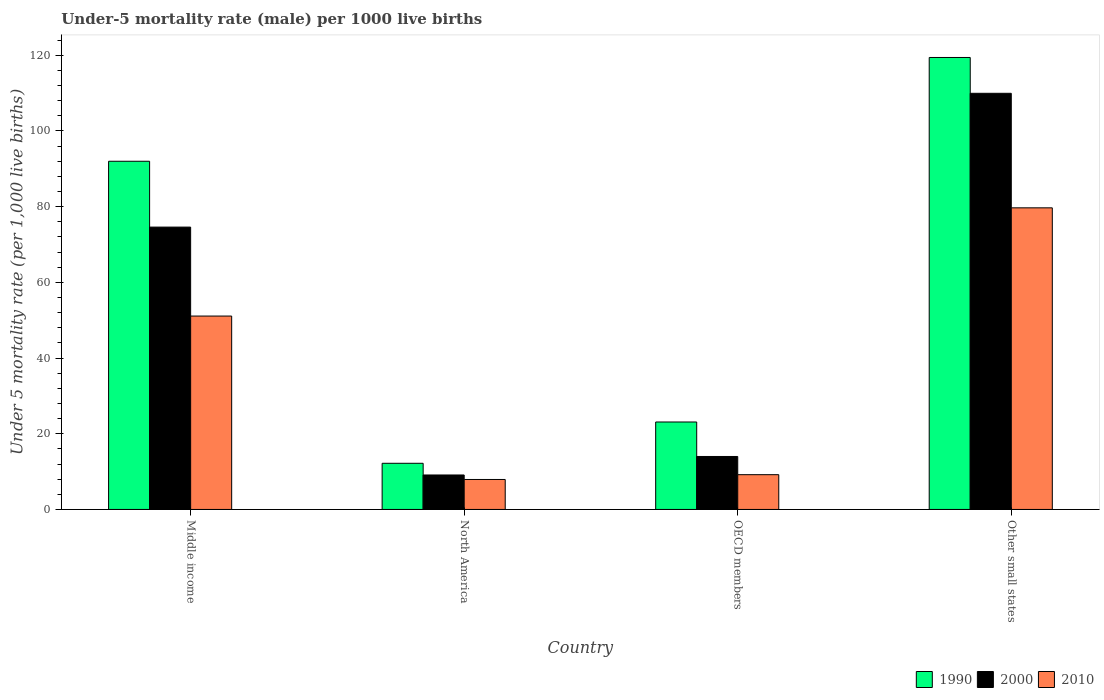How many groups of bars are there?
Your answer should be very brief. 4. Are the number of bars per tick equal to the number of legend labels?
Provide a succinct answer. Yes. Are the number of bars on each tick of the X-axis equal?
Provide a succinct answer. Yes. What is the under-five mortality rate in 2000 in Other small states?
Provide a succinct answer. 109.95. Across all countries, what is the maximum under-five mortality rate in 1990?
Provide a short and direct response. 119.42. Across all countries, what is the minimum under-five mortality rate in 1990?
Provide a succinct answer. 12.2. In which country was the under-five mortality rate in 2010 maximum?
Give a very brief answer. Other small states. In which country was the under-five mortality rate in 2000 minimum?
Your answer should be compact. North America. What is the total under-five mortality rate in 1990 in the graph?
Make the answer very short. 246.73. What is the difference between the under-five mortality rate in 2010 in North America and that in OECD members?
Offer a very short reply. -1.26. What is the difference between the under-five mortality rate in 1990 in OECD members and the under-five mortality rate in 2010 in Other small states?
Provide a succinct answer. -56.58. What is the average under-five mortality rate in 1990 per country?
Make the answer very short. 61.68. What is the difference between the under-five mortality rate of/in 2000 and under-five mortality rate of/in 2010 in OECD members?
Ensure brevity in your answer.  4.81. In how many countries, is the under-five mortality rate in 2000 greater than 68?
Your answer should be very brief. 2. What is the ratio of the under-five mortality rate in 2010 in Middle income to that in North America?
Make the answer very short. 6.45. Is the under-five mortality rate in 1990 in Middle income less than that in North America?
Ensure brevity in your answer.  No. What is the difference between the highest and the second highest under-five mortality rate in 1990?
Ensure brevity in your answer.  68.89. What is the difference between the highest and the lowest under-five mortality rate in 2000?
Give a very brief answer. 100.84. In how many countries, is the under-five mortality rate in 2010 greater than the average under-five mortality rate in 2010 taken over all countries?
Make the answer very short. 2. What does the 3rd bar from the left in Middle income represents?
Your response must be concise. 2010. Is it the case that in every country, the sum of the under-five mortality rate in 1990 and under-five mortality rate in 2010 is greater than the under-five mortality rate in 2000?
Keep it short and to the point. Yes. Are all the bars in the graph horizontal?
Your answer should be very brief. No. What is the difference between two consecutive major ticks on the Y-axis?
Make the answer very short. 20. Are the values on the major ticks of Y-axis written in scientific E-notation?
Provide a short and direct response. No. Does the graph contain any zero values?
Give a very brief answer. No. How many legend labels are there?
Give a very brief answer. 3. How are the legend labels stacked?
Your response must be concise. Horizontal. What is the title of the graph?
Offer a terse response. Under-5 mortality rate (male) per 1000 live births. What is the label or title of the Y-axis?
Ensure brevity in your answer.  Under 5 mortality rate (per 1,0 live births). What is the Under 5 mortality rate (per 1,000 live births) of 1990 in Middle income?
Your response must be concise. 92. What is the Under 5 mortality rate (per 1,000 live births) of 2000 in Middle income?
Give a very brief answer. 74.6. What is the Under 5 mortality rate (per 1,000 live births) of 2010 in Middle income?
Keep it short and to the point. 51.1. What is the Under 5 mortality rate (per 1,000 live births) of 1990 in North America?
Your response must be concise. 12.2. What is the Under 5 mortality rate (per 1,000 live births) in 2000 in North America?
Offer a terse response. 9.11. What is the Under 5 mortality rate (per 1,000 live births) in 2010 in North America?
Keep it short and to the point. 7.92. What is the Under 5 mortality rate (per 1,000 live births) of 1990 in OECD members?
Make the answer very short. 23.11. What is the Under 5 mortality rate (per 1,000 live births) in 2000 in OECD members?
Your response must be concise. 14. What is the Under 5 mortality rate (per 1,000 live births) of 2010 in OECD members?
Give a very brief answer. 9.19. What is the Under 5 mortality rate (per 1,000 live births) of 1990 in Other small states?
Offer a very short reply. 119.42. What is the Under 5 mortality rate (per 1,000 live births) in 2000 in Other small states?
Your response must be concise. 109.95. What is the Under 5 mortality rate (per 1,000 live births) of 2010 in Other small states?
Make the answer very short. 79.69. Across all countries, what is the maximum Under 5 mortality rate (per 1,000 live births) in 1990?
Provide a short and direct response. 119.42. Across all countries, what is the maximum Under 5 mortality rate (per 1,000 live births) in 2000?
Keep it short and to the point. 109.95. Across all countries, what is the maximum Under 5 mortality rate (per 1,000 live births) in 2010?
Your answer should be compact. 79.69. Across all countries, what is the minimum Under 5 mortality rate (per 1,000 live births) in 1990?
Make the answer very short. 12.2. Across all countries, what is the minimum Under 5 mortality rate (per 1,000 live births) in 2000?
Offer a very short reply. 9.11. Across all countries, what is the minimum Under 5 mortality rate (per 1,000 live births) in 2010?
Give a very brief answer. 7.92. What is the total Under 5 mortality rate (per 1,000 live births) in 1990 in the graph?
Make the answer very short. 246.73. What is the total Under 5 mortality rate (per 1,000 live births) of 2000 in the graph?
Provide a short and direct response. 207.66. What is the total Under 5 mortality rate (per 1,000 live births) of 2010 in the graph?
Give a very brief answer. 147.9. What is the difference between the Under 5 mortality rate (per 1,000 live births) of 1990 in Middle income and that in North America?
Your answer should be very brief. 79.8. What is the difference between the Under 5 mortality rate (per 1,000 live births) in 2000 in Middle income and that in North America?
Your answer should be compact. 65.49. What is the difference between the Under 5 mortality rate (per 1,000 live births) in 2010 in Middle income and that in North America?
Make the answer very short. 43.18. What is the difference between the Under 5 mortality rate (per 1,000 live births) of 1990 in Middle income and that in OECD members?
Your answer should be compact. 68.89. What is the difference between the Under 5 mortality rate (per 1,000 live births) in 2000 in Middle income and that in OECD members?
Ensure brevity in your answer.  60.6. What is the difference between the Under 5 mortality rate (per 1,000 live births) of 2010 in Middle income and that in OECD members?
Your answer should be compact. 41.91. What is the difference between the Under 5 mortality rate (per 1,000 live births) of 1990 in Middle income and that in Other small states?
Offer a terse response. -27.42. What is the difference between the Under 5 mortality rate (per 1,000 live births) of 2000 in Middle income and that in Other small states?
Give a very brief answer. -35.35. What is the difference between the Under 5 mortality rate (per 1,000 live births) of 2010 in Middle income and that in Other small states?
Your response must be concise. -28.59. What is the difference between the Under 5 mortality rate (per 1,000 live births) of 1990 in North America and that in OECD members?
Provide a short and direct response. -10.91. What is the difference between the Under 5 mortality rate (per 1,000 live births) of 2000 in North America and that in OECD members?
Provide a short and direct response. -4.89. What is the difference between the Under 5 mortality rate (per 1,000 live births) of 2010 in North America and that in OECD members?
Offer a very short reply. -1.26. What is the difference between the Under 5 mortality rate (per 1,000 live births) of 1990 in North America and that in Other small states?
Your response must be concise. -107.22. What is the difference between the Under 5 mortality rate (per 1,000 live births) in 2000 in North America and that in Other small states?
Keep it short and to the point. -100.84. What is the difference between the Under 5 mortality rate (per 1,000 live births) of 2010 in North America and that in Other small states?
Your response must be concise. -71.77. What is the difference between the Under 5 mortality rate (per 1,000 live births) of 1990 in OECD members and that in Other small states?
Keep it short and to the point. -96.31. What is the difference between the Under 5 mortality rate (per 1,000 live births) in 2000 in OECD members and that in Other small states?
Provide a succinct answer. -95.95. What is the difference between the Under 5 mortality rate (per 1,000 live births) in 2010 in OECD members and that in Other small states?
Offer a terse response. -70.51. What is the difference between the Under 5 mortality rate (per 1,000 live births) in 1990 in Middle income and the Under 5 mortality rate (per 1,000 live births) in 2000 in North America?
Give a very brief answer. 82.89. What is the difference between the Under 5 mortality rate (per 1,000 live births) in 1990 in Middle income and the Under 5 mortality rate (per 1,000 live births) in 2010 in North America?
Provide a succinct answer. 84.08. What is the difference between the Under 5 mortality rate (per 1,000 live births) in 2000 in Middle income and the Under 5 mortality rate (per 1,000 live births) in 2010 in North America?
Ensure brevity in your answer.  66.68. What is the difference between the Under 5 mortality rate (per 1,000 live births) in 1990 in Middle income and the Under 5 mortality rate (per 1,000 live births) in 2000 in OECD members?
Make the answer very short. 78. What is the difference between the Under 5 mortality rate (per 1,000 live births) in 1990 in Middle income and the Under 5 mortality rate (per 1,000 live births) in 2010 in OECD members?
Keep it short and to the point. 82.81. What is the difference between the Under 5 mortality rate (per 1,000 live births) in 2000 in Middle income and the Under 5 mortality rate (per 1,000 live births) in 2010 in OECD members?
Your response must be concise. 65.41. What is the difference between the Under 5 mortality rate (per 1,000 live births) of 1990 in Middle income and the Under 5 mortality rate (per 1,000 live births) of 2000 in Other small states?
Make the answer very short. -17.95. What is the difference between the Under 5 mortality rate (per 1,000 live births) of 1990 in Middle income and the Under 5 mortality rate (per 1,000 live births) of 2010 in Other small states?
Give a very brief answer. 12.31. What is the difference between the Under 5 mortality rate (per 1,000 live births) in 2000 in Middle income and the Under 5 mortality rate (per 1,000 live births) in 2010 in Other small states?
Give a very brief answer. -5.09. What is the difference between the Under 5 mortality rate (per 1,000 live births) in 1990 in North America and the Under 5 mortality rate (per 1,000 live births) in 2000 in OECD members?
Your answer should be very brief. -1.8. What is the difference between the Under 5 mortality rate (per 1,000 live births) of 1990 in North America and the Under 5 mortality rate (per 1,000 live births) of 2010 in OECD members?
Provide a short and direct response. 3.01. What is the difference between the Under 5 mortality rate (per 1,000 live births) in 2000 in North America and the Under 5 mortality rate (per 1,000 live births) in 2010 in OECD members?
Offer a very short reply. -0.08. What is the difference between the Under 5 mortality rate (per 1,000 live births) of 1990 in North America and the Under 5 mortality rate (per 1,000 live births) of 2000 in Other small states?
Offer a terse response. -97.75. What is the difference between the Under 5 mortality rate (per 1,000 live births) of 1990 in North America and the Under 5 mortality rate (per 1,000 live births) of 2010 in Other small states?
Provide a succinct answer. -67.49. What is the difference between the Under 5 mortality rate (per 1,000 live births) of 2000 in North America and the Under 5 mortality rate (per 1,000 live births) of 2010 in Other small states?
Give a very brief answer. -70.59. What is the difference between the Under 5 mortality rate (per 1,000 live births) of 1990 in OECD members and the Under 5 mortality rate (per 1,000 live births) of 2000 in Other small states?
Provide a succinct answer. -86.84. What is the difference between the Under 5 mortality rate (per 1,000 live births) in 1990 in OECD members and the Under 5 mortality rate (per 1,000 live births) in 2010 in Other small states?
Your response must be concise. -56.58. What is the difference between the Under 5 mortality rate (per 1,000 live births) in 2000 in OECD members and the Under 5 mortality rate (per 1,000 live births) in 2010 in Other small states?
Give a very brief answer. -65.7. What is the average Under 5 mortality rate (per 1,000 live births) of 1990 per country?
Offer a very short reply. 61.68. What is the average Under 5 mortality rate (per 1,000 live births) in 2000 per country?
Your response must be concise. 51.91. What is the average Under 5 mortality rate (per 1,000 live births) in 2010 per country?
Your answer should be compact. 36.98. What is the difference between the Under 5 mortality rate (per 1,000 live births) of 1990 and Under 5 mortality rate (per 1,000 live births) of 2010 in Middle income?
Offer a very short reply. 40.9. What is the difference between the Under 5 mortality rate (per 1,000 live births) in 2000 and Under 5 mortality rate (per 1,000 live births) in 2010 in Middle income?
Your answer should be very brief. 23.5. What is the difference between the Under 5 mortality rate (per 1,000 live births) in 1990 and Under 5 mortality rate (per 1,000 live births) in 2000 in North America?
Give a very brief answer. 3.09. What is the difference between the Under 5 mortality rate (per 1,000 live births) in 1990 and Under 5 mortality rate (per 1,000 live births) in 2010 in North America?
Make the answer very short. 4.28. What is the difference between the Under 5 mortality rate (per 1,000 live births) of 2000 and Under 5 mortality rate (per 1,000 live births) of 2010 in North America?
Ensure brevity in your answer.  1.19. What is the difference between the Under 5 mortality rate (per 1,000 live births) of 1990 and Under 5 mortality rate (per 1,000 live births) of 2000 in OECD members?
Provide a succinct answer. 9.11. What is the difference between the Under 5 mortality rate (per 1,000 live births) in 1990 and Under 5 mortality rate (per 1,000 live births) in 2010 in OECD members?
Your response must be concise. 13.92. What is the difference between the Under 5 mortality rate (per 1,000 live births) of 2000 and Under 5 mortality rate (per 1,000 live births) of 2010 in OECD members?
Give a very brief answer. 4.81. What is the difference between the Under 5 mortality rate (per 1,000 live births) of 1990 and Under 5 mortality rate (per 1,000 live births) of 2000 in Other small states?
Offer a very short reply. 9.47. What is the difference between the Under 5 mortality rate (per 1,000 live births) in 1990 and Under 5 mortality rate (per 1,000 live births) in 2010 in Other small states?
Ensure brevity in your answer.  39.73. What is the difference between the Under 5 mortality rate (per 1,000 live births) of 2000 and Under 5 mortality rate (per 1,000 live births) of 2010 in Other small states?
Ensure brevity in your answer.  30.26. What is the ratio of the Under 5 mortality rate (per 1,000 live births) in 1990 in Middle income to that in North America?
Your answer should be very brief. 7.54. What is the ratio of the Under 5 mortality rate (per 1,000 live births) of 2000 in Middle income to that in North America?
Ensure brevity in your answer.  8.19. What is the ratio of the Under 5 mortality rate (per 1,000 live births) in 2010 in Middle income to that in North America?
Provide a succinct answer. 6.45. What is the ratio of the Under 5 mortality rate (per 1,000 live births) in 1990 in Middle income to that in OECD members?
Your answer should be very brief. 3.98. What is the ratio of the Under 5 mortality rate (per 1,000 live births) of 2000 in Middle income to that in OECD members?
Your answer should be compact. 5.33. What is the ratio of the Under 5 mortality rate (per 1,000 live births) of 2010 in Middle income to that in OECD members?
Your answer should be compact. 5.56. What is the ratio of the Under 5 mortality rate (per 1,000 live births) of 1990 in Middle income to that in Other small states?
Your answer should be very brief. 0.77. What is the ratio of the Under 5 mortality rate (per 1,000 live births) in 2000 in Middle income to that in Other small states?
Provide a short and direct response. 0.68. What is the ratio of the Under 5 mortality rate (per 1,000 live births) in 2010 in Middle income to that in Other small states?
Provide a short and direct response. 0.64. What is the ratio of the Under 5 mortality rate (per 1,000 live births) of 1990 in North America to that in OECD members?
Keep it short and to the point. 0.53. What is the ratio of the Under 5 mortality rate (per 1,000 live births) of 2000 in North America to that in OECD members?
Keep it short and to the point. 0.65. What is the ratio of the Under 5 mortality rate (per 1,000 live births) in 2010 in North America to that in OECD members?
Offer a very short reply. 0.86. What is the ratio of the Under 5 mortality rate (per 1,000 live births) of 1990 in North America to that in Other small states?
Ensure brevity in your answer.  0.1. What is the ratio of the Under 5 mortality rate (per 1,000 live births) of 2000 in North America to that in Other small states?
Ensure brevity in your answer.  0.08. What is the ratio of the Under 5 mortality rate (per 1,000 live births) in 2010 in North America to that in Other small states?
Your answer should be compact. 0.1. What is the ratio of the Under 5 mortality rate (per 1,000 live births) in 1990 in OECD members to that in Other small states?
Offer a very short reply. 0.19. What is the ratio of the Under 5 mortality rate (per 1,000 live births) in 2000 in OECD members to that in Other small states?
Ensure brevity in your answer.  0.13. What is the ratio of the Under 5 mortality rate (per 1,000 live births) of 2010 in OECD members to that in Other small states?
Keep it short and to the point. 0.12. What is the difference between the highest and the second highest Under 5 mortality rate (per 1,000 live births) in 1990?
Your response must be concise. 27.42. What is the difference between the highest and the second highest Under 5 mortality rate (per 1,000 live births) of 2000?
Make the answer very short. 35.35. What is the difference between the highest and the second highest Under 5 mortality rate (per 1,000 live births) in 2010?
Make the answer very short. 28.59. What is the difference between the highest and the lowest Under 5 mortality rate (per 1,000 live births) of 1990?
Provide a short and direct response. 107.22. What is the difference between the highest and the lowest Under 5 mortality rate (per 1,000 live births) in 2000?
Make the answer very short. 100.84. What is the difference between the highest and the lowest Under 5 mortality rate (per 1,000 live births) in 2010?
Your answer should be very brief. 71.77. 